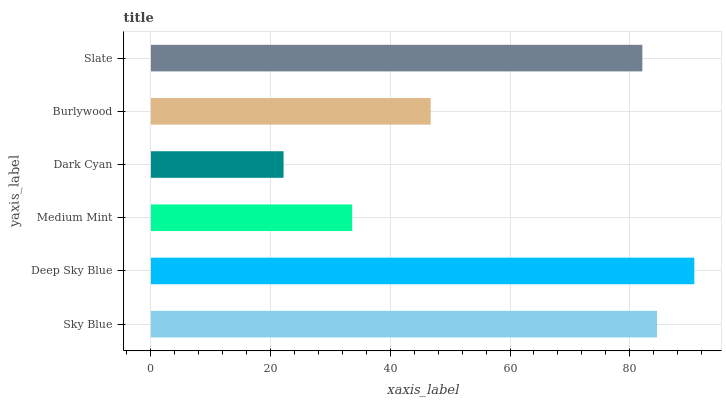Is Dark Cyan the minimum?
Answer yes or no. Yes. Is Deep Sky Blue the maximum?
Answer yes or no. Yes. Is Medium Mint the minimum?
Answer yes or no. No. Is Medium Mint the maximum?
Answer yes or no. No. Is Deep Sky Blue greater than Medium Mint?
Answer yes or no. Yes. Is Medium Mint less than Deep Sky Blue?
Answer yes or no. Yes. Is Medium Mint greater than Deep Sky Blue?
Answer yes or no. No. Is Deep Sky Blue less than Medium Mint?
Answer yes or no. No. Is Slate the high median?
Answer yes or no. Yes. Is Burlywood the low median?
Answer yes or no. Yes. Is Dark Cyan the high median?
Answer yes or no. No. Is Dark Cyan the low median?
Answer yes or no. No. 